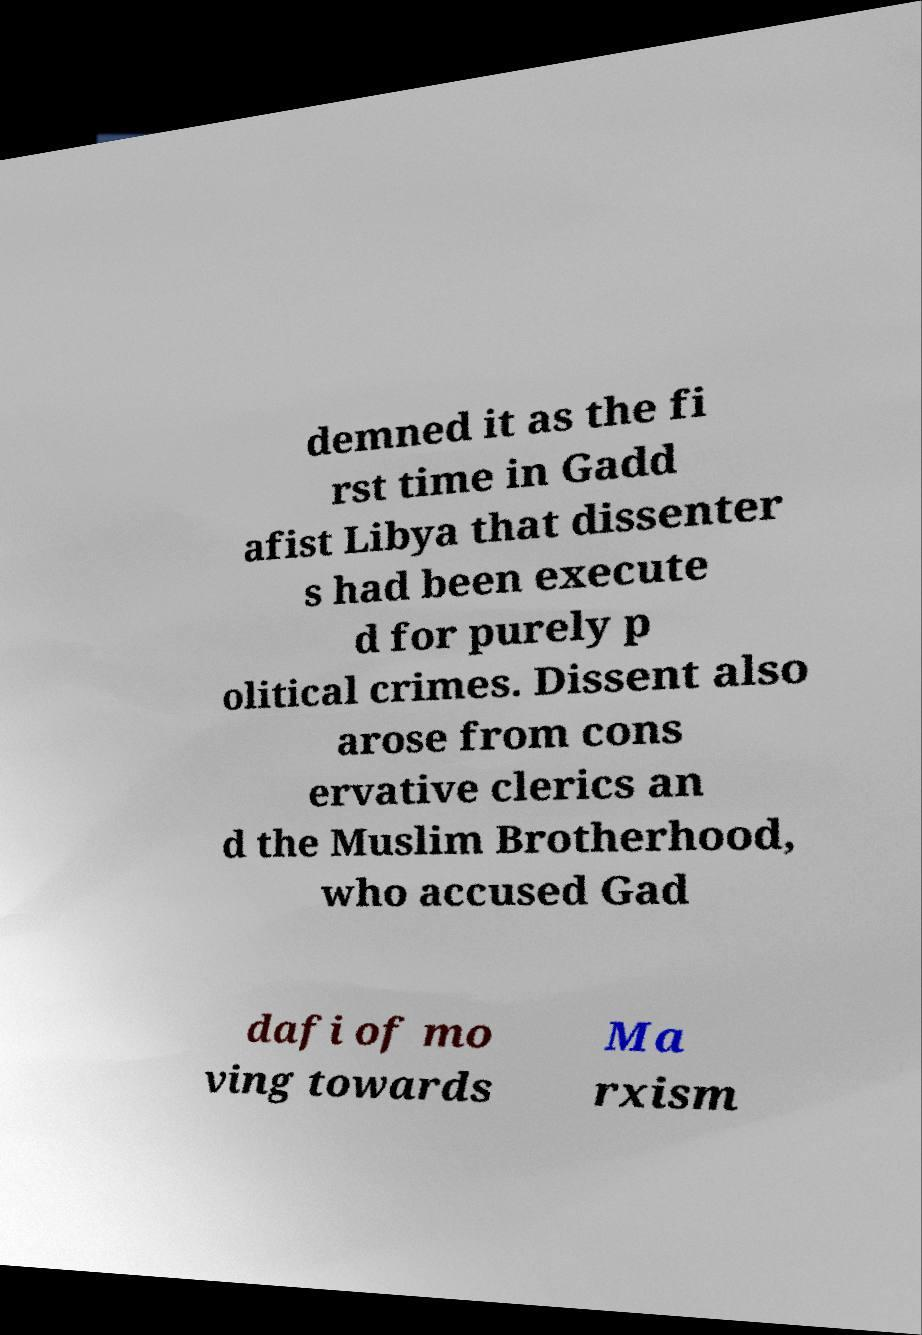Can you accurately transcribe the text from the provided image for me? demned it as the fi rst time in Gadd afist Libya that dissenter s had been execute d for purely p olitical crimes. Dissent also arose from cons ervative clerics an d the Muslim Brotherhood, who accused Gad dafi of mo ving towards Ma rxism 